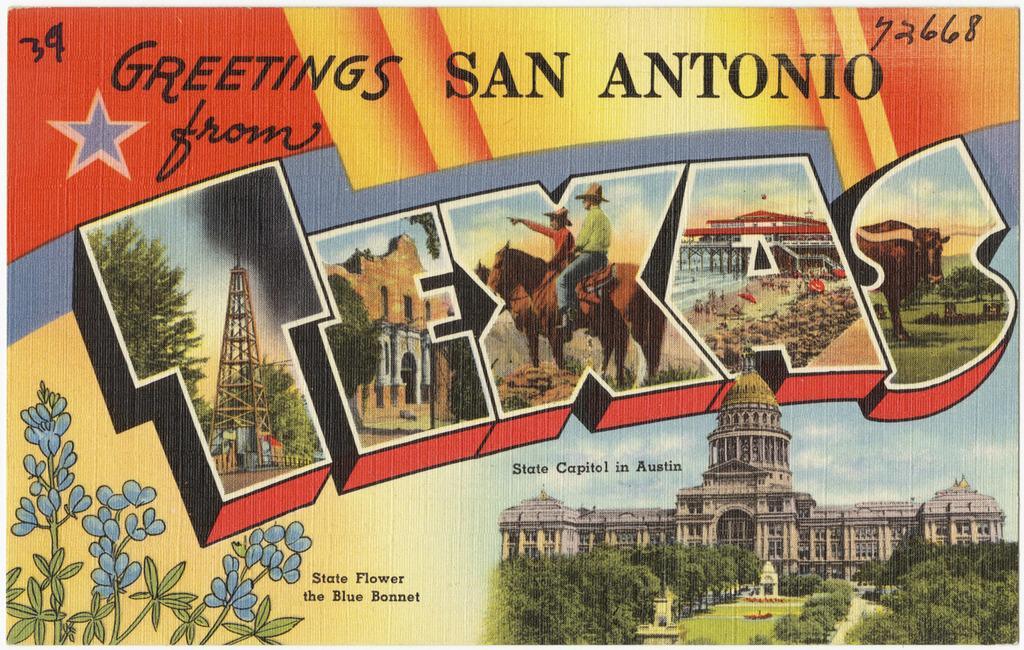Could you give a brief overview of what you see in this image? In this image there is a greeting card with pictures of buildings, trees, people, horses, metal structures and there is some text on the image. 